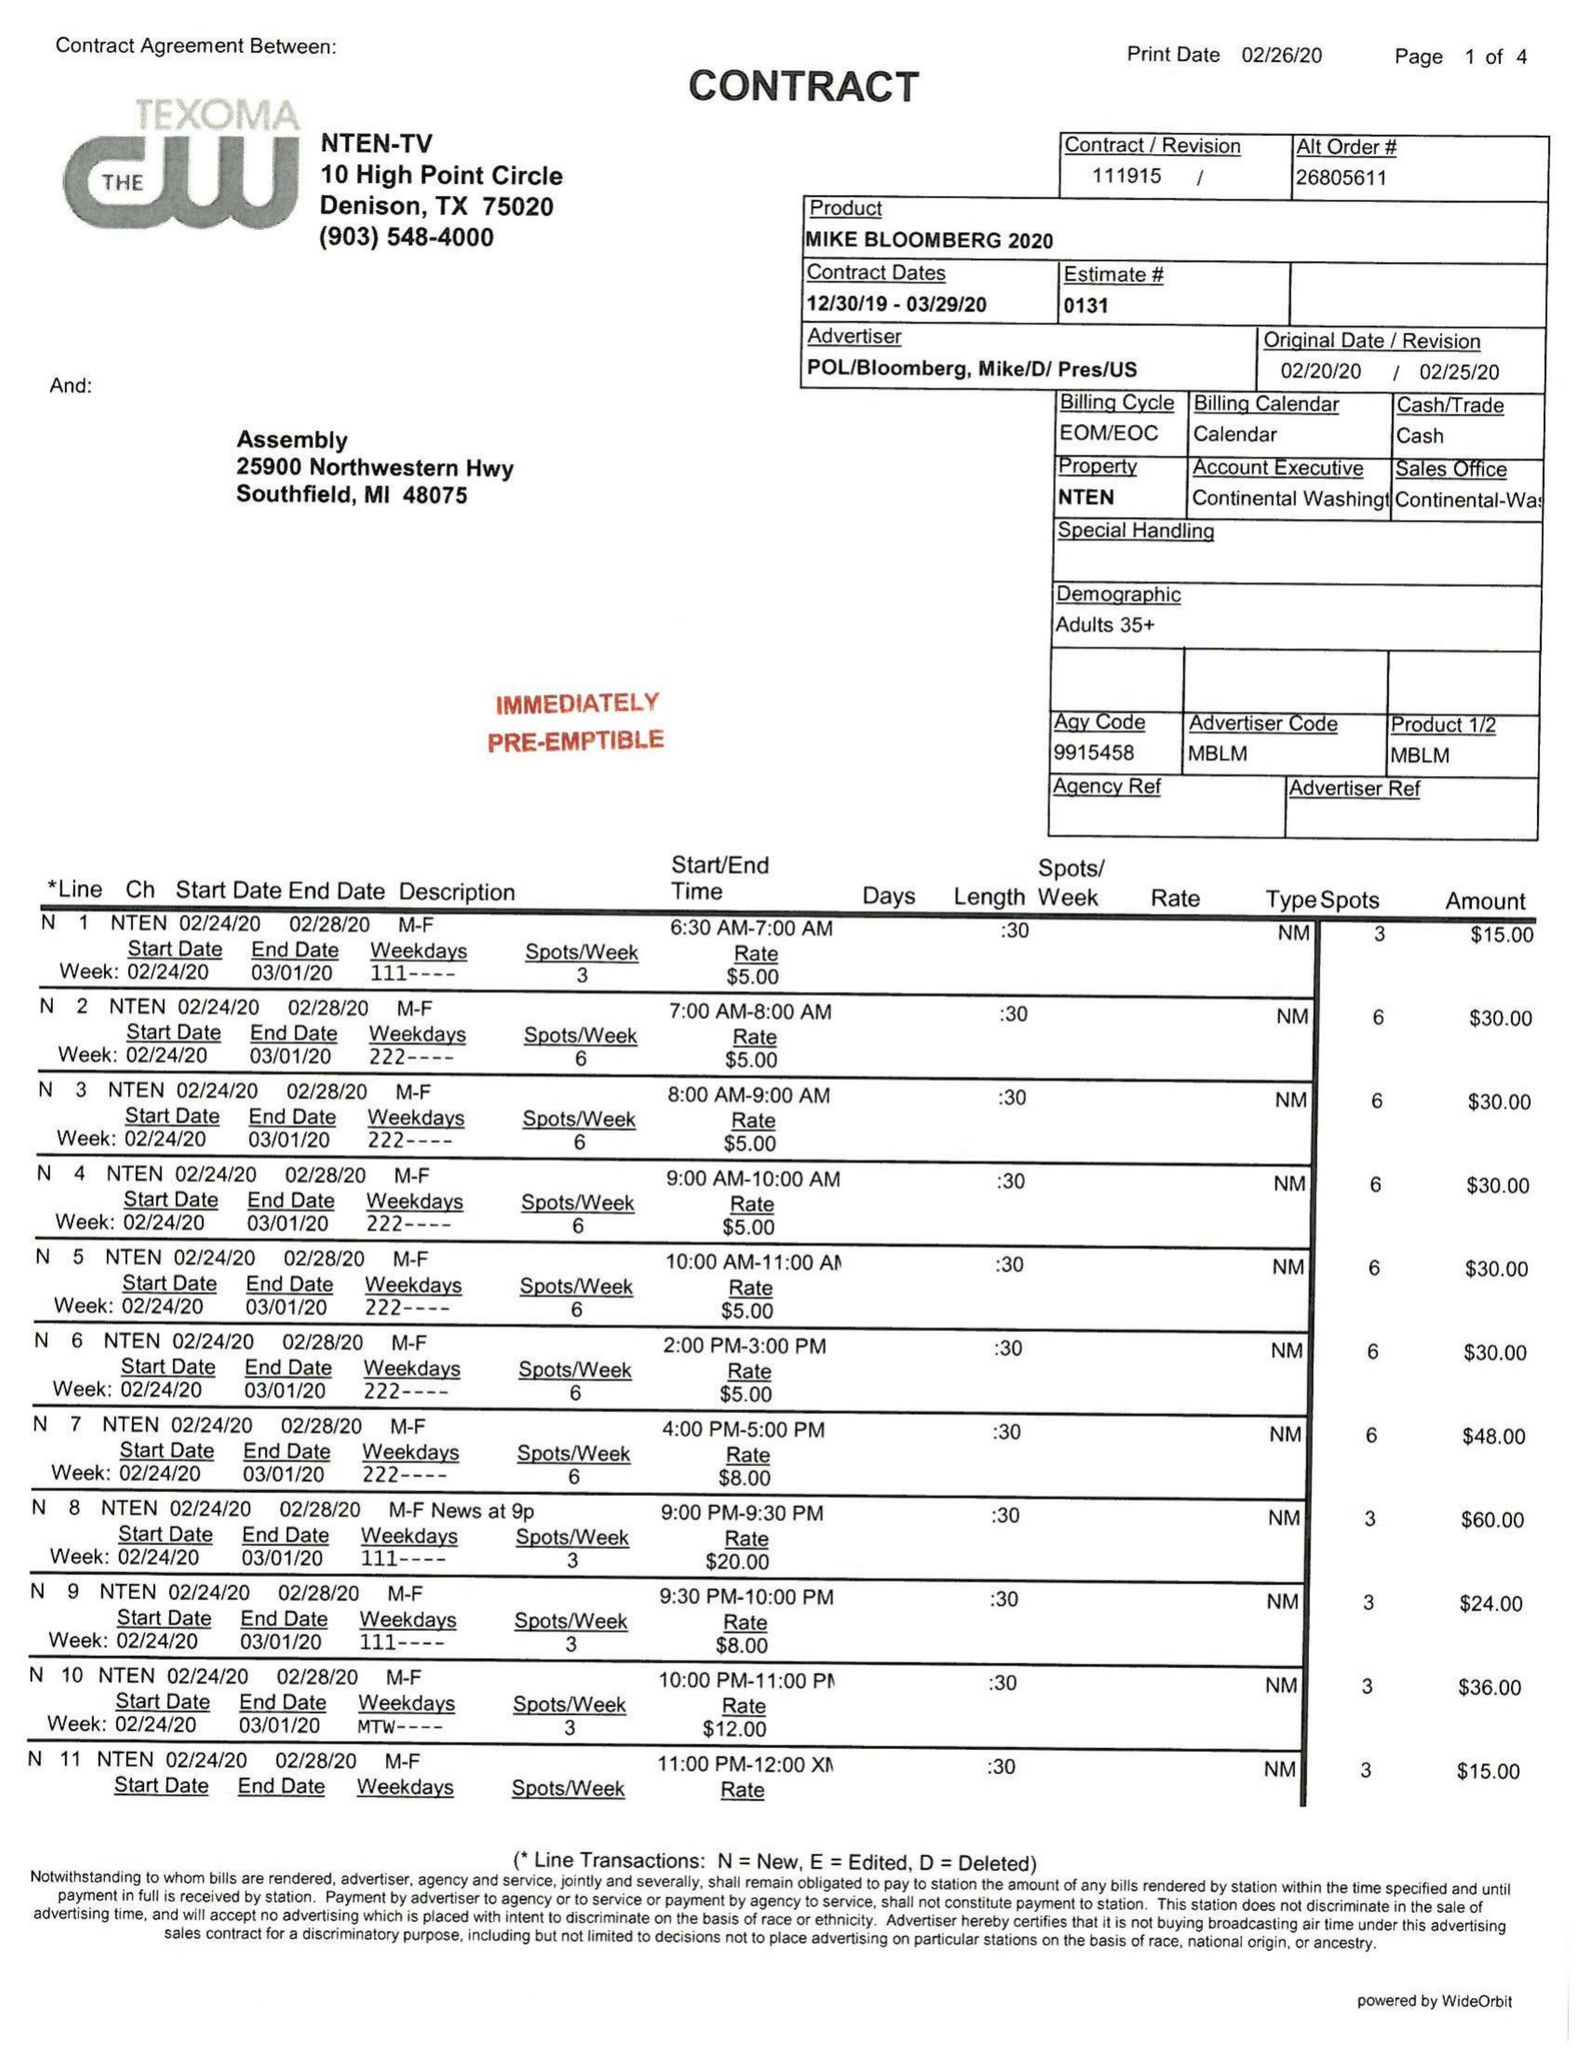What is the value for the flight_to?
Answer the question using a single word or phrase. 03/29/20 